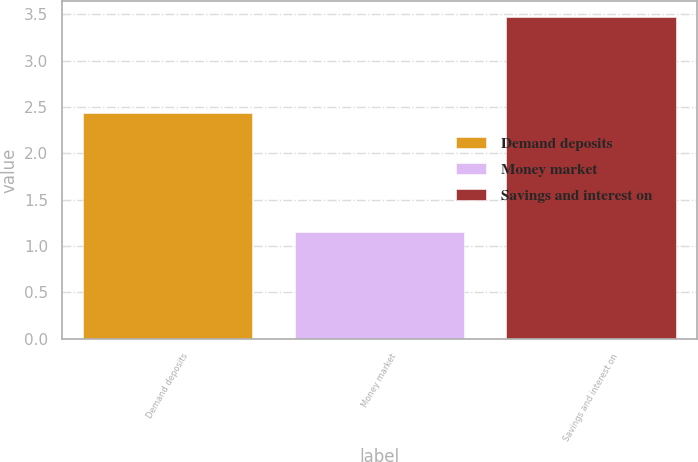Convert chart. <chart><loc_0><loc_0><loc_500><loc_500><bar_chart><fcel>Demand deposits<fcel>Money market<fcel>Savings and interest on<nl><fcel>2.44<fcel>1.15<fcel>3.47<nl></chart> 